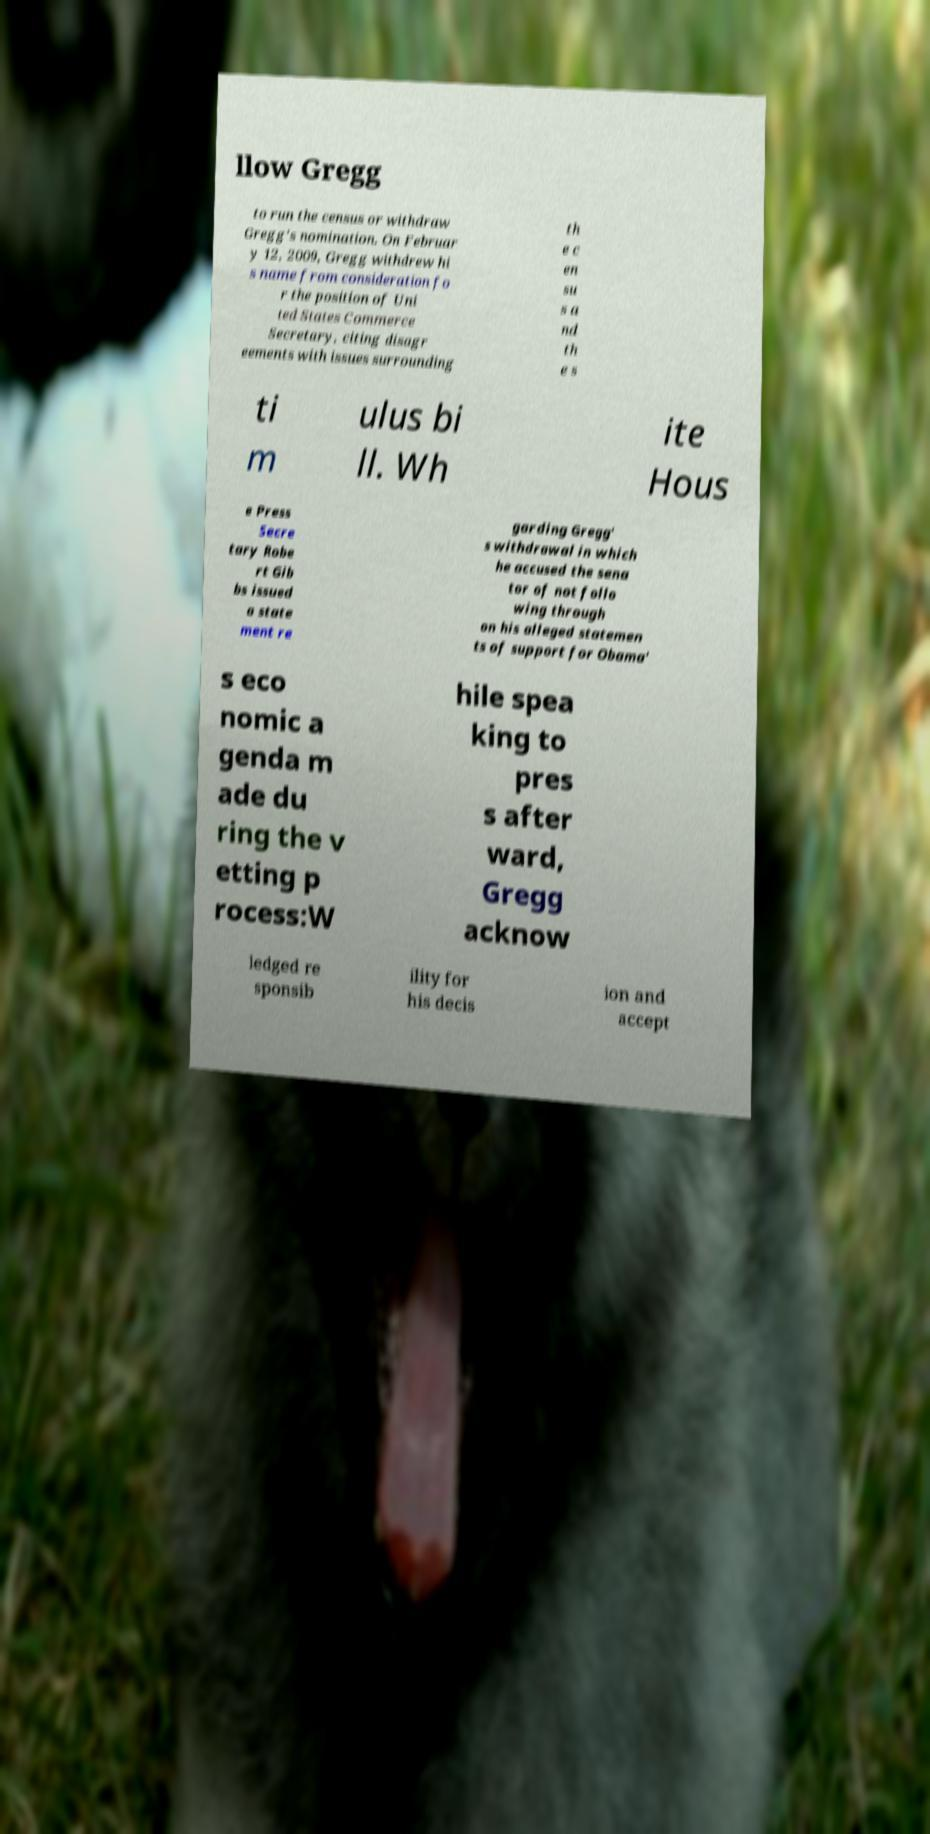I need the written content from this picture converted into text. Can you do that? llow Gregg to run the census or withdraw Gregg's nomination. On Februar y 12, 2009, Gregg withdrew hi s name from consideration fo r the position of Uni ted States Commerce Secretary, citing disagr eements with issues surrounding th e c en su s a nd th e s ti m ulus bi ll. Wh ite Hous e Press Secre tary Robe rt Gib bs issued a state ment re garding Gregg' s withdrawal in which he accused the sena tor of not follo wing through on his alleged statemen ts of support for Obama' s eco nomic a genda m ade du ring the v etting p rocess:W hile spea king to pres s after ward, Gregg acknow ledged re sponsib ility for his decis ion and accept 